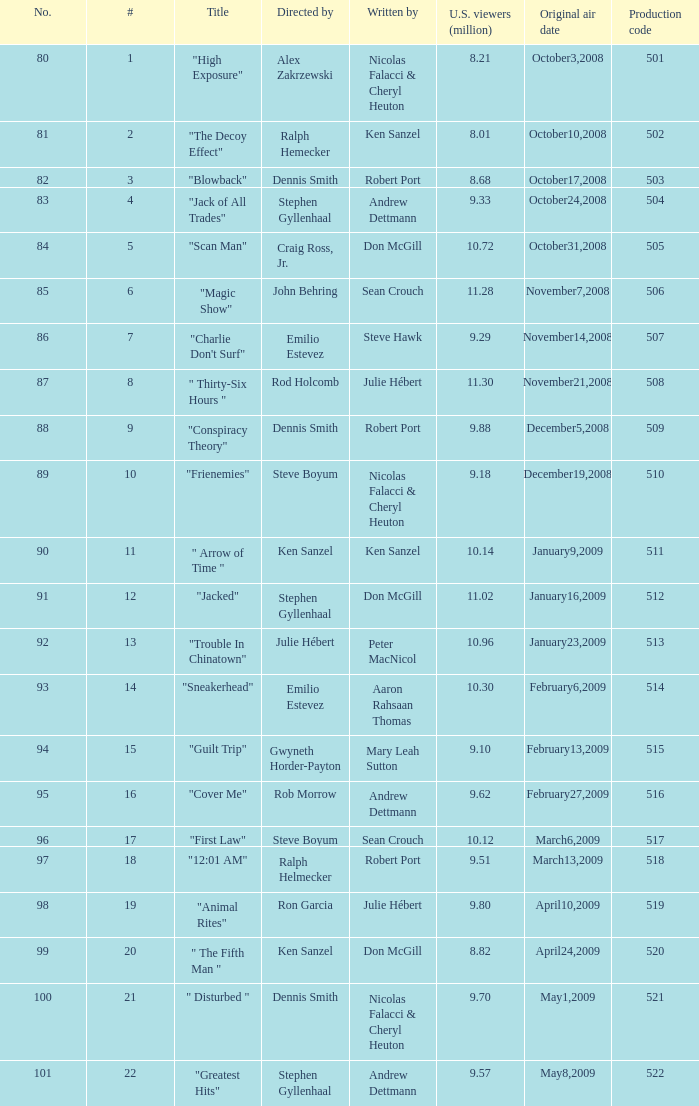Which episode number was helmed by craig ross, jr.? 5.0. 